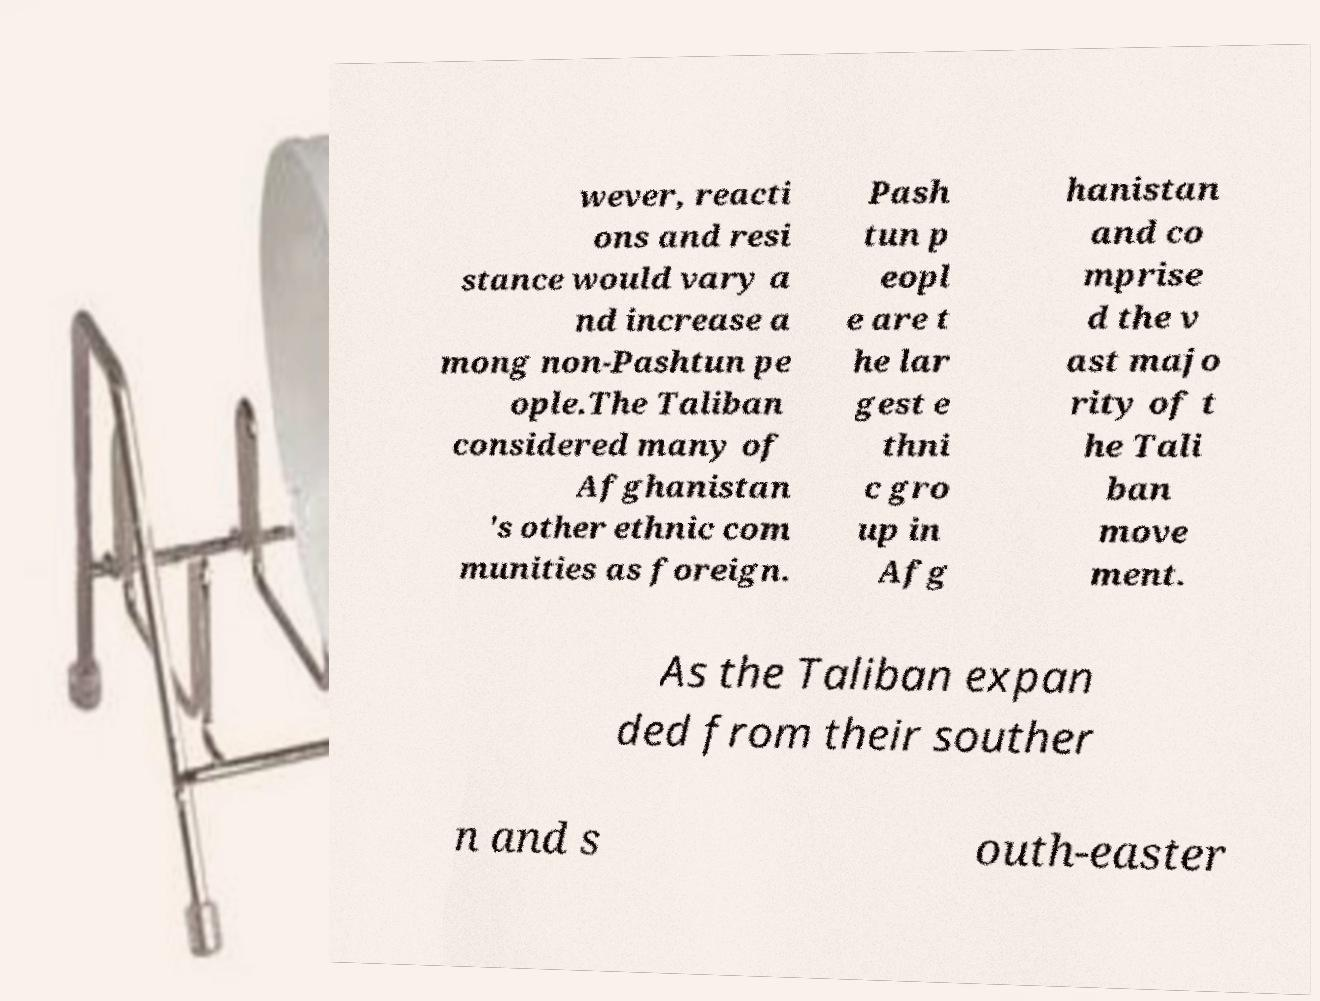Can you read and provide the text displayed in the image?This photo seems to have some interesting text. Can you extract and type it out for me? wever, reacti ons and resi stance would vary a nd increase a mong non-Pashtun pe ople.The Taliban considered many of Afghanistan 's other ethnic com munities as foreign. Pash tun p eopl e are t he lar gest e thni c gro up in Afg hanistan and co mprise d the v ast majo rity of t he Tali ban move ment. As the Taliban expan ded from their souther n and s outh-easter 